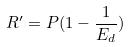<formula> <loc_0><loc_0><loc_500><loc_500>R ^ { \prime } = P ( 1 - \frac { 1 } { E _ { d } } )</formula> 